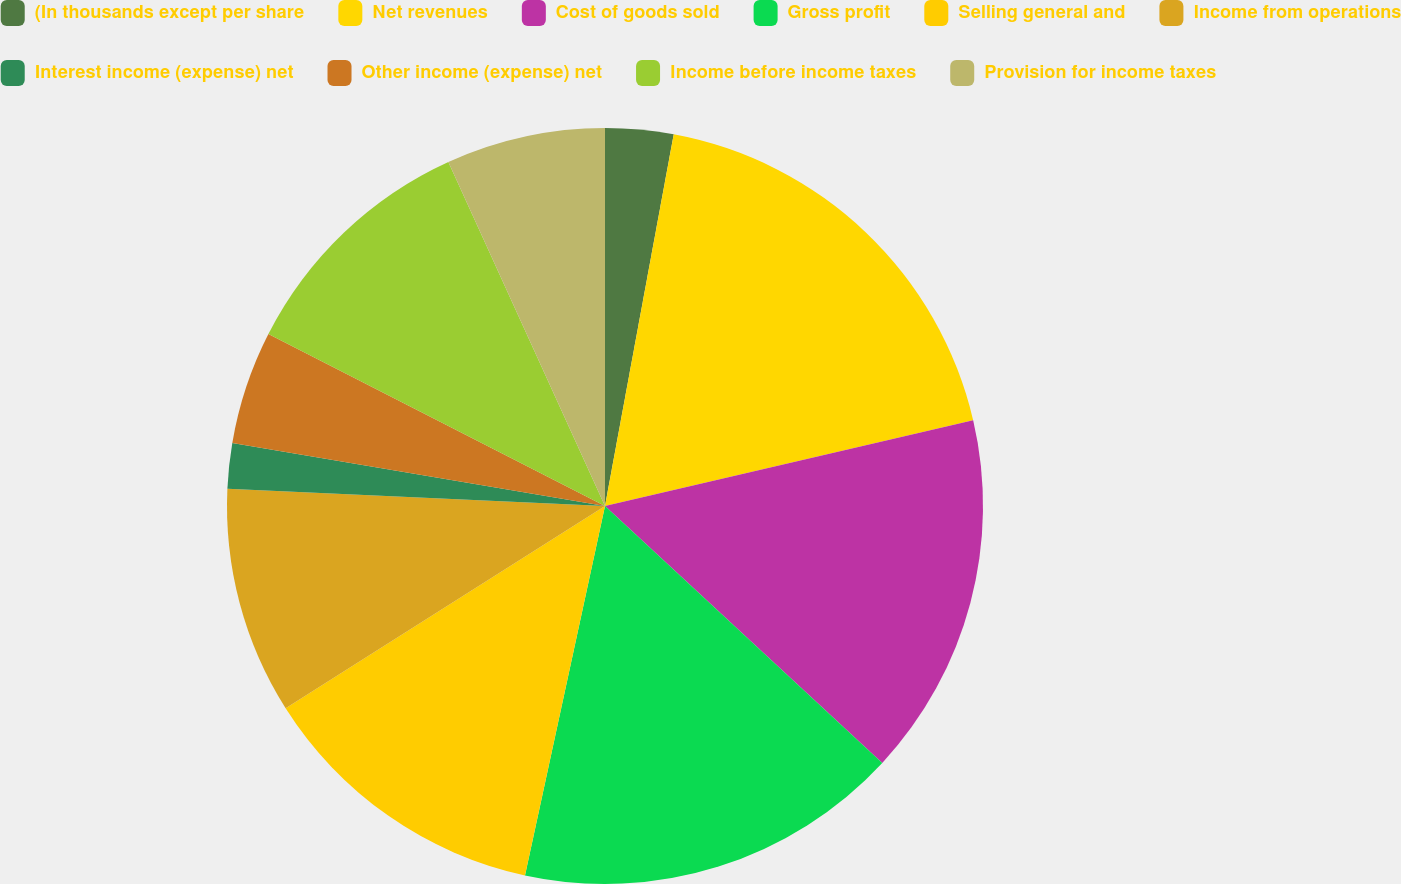Convert chart. <chart><loc_0><loc_0><loc_500><loc_500><pie_chart><fcel>(In thousands except per share<fcel>Net revenues<fcel>Cost of goods sold<fcel>Gross profit<fcel>Selling general and<fcel>Income from operations<fcel>Interest income (expense) net<fcel>Other income (expense) net<fcel>Income before income taxes<fcel>Provision for income taxes<nl><fcel>2.91%<fcel>18.45%<fcel>15.53%<fcel>16.5%<fcel>12.62%<fcel>9.71%<fcel>1.94%<fcel>4.85%<fcel>10.68%<fcel>6.8%<nl></chart> 